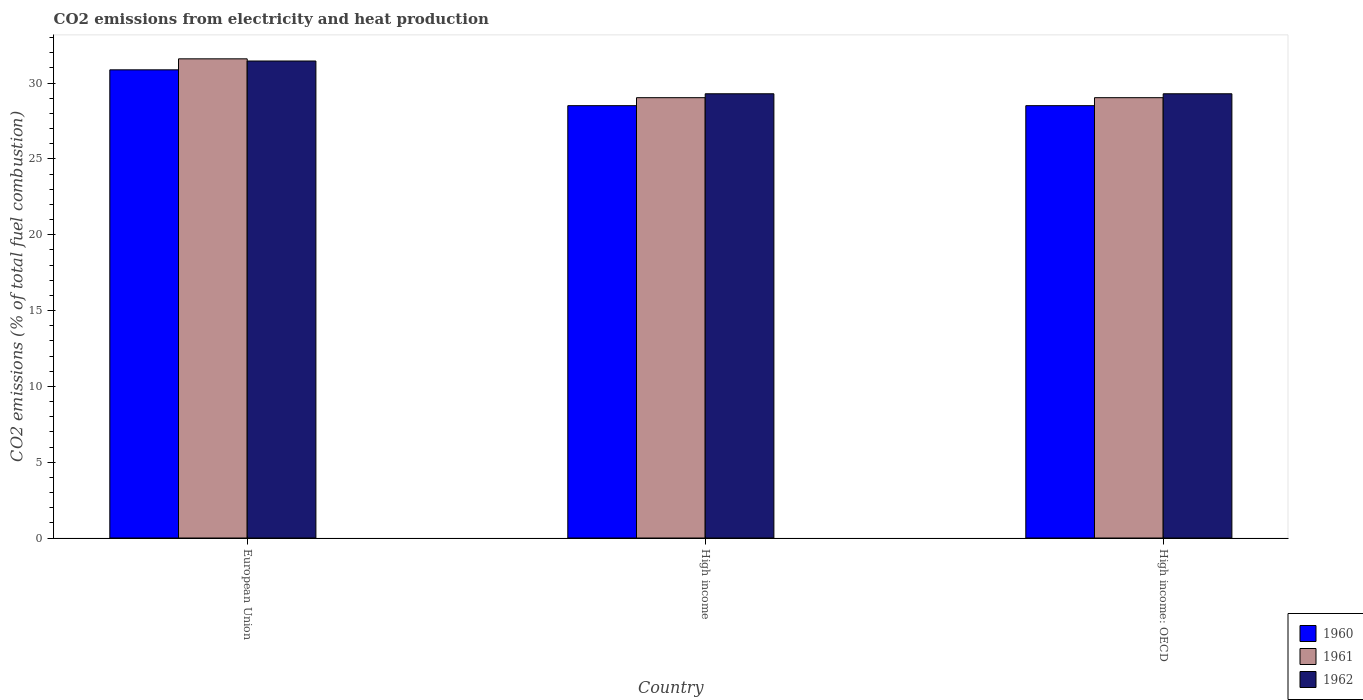How many different coloured bars are there?
Make the answer very short. 3. Are the number of bars per tick equal to the number of legend labels?
Provide a short and direct response. Yes. How many bars are there on the 1st tick from the left?
Keep it short and to the point. 3. What is the amount of CO2 emitted in 1962 in European Union?
Keep it short and to the point. 31.45. Across all countries, what is the maximum amount of CO2 emitted in 1962?
Give a very brief answer. 31.45. Across all countries, what is the minimum amount of CO2 emitted in 1961?
Provide a succinct answer. 29.03. In which country was the amount of CO2 emitted in 1962 minimum?
Offer a very short reply. High income. What is the total amount of CO2 emitted in 1960 in the graph?
Your response must be concise. 87.88. What is the difference between the amount of CO2 emitted in 1960 in High income: OECD and the amount of CO2 emitted in 1961 in European Union?
Make the answer very short. -3.09. What is the average amount of CO2 emitted in 1960 per country?
Offer a very short reply. 29.29. What is the difference between the amount of CO2 emitted of/in 1960 and amount of CO2 emitted of/in 1961 in European Union?
Offer a terse response. -0.73. What is the ratio of the amount of CO2 emitted in 1962 in European Union to that in High income: OECD?
Keep it short and to the point. 1.07. Is the amount of CO2 emitted in 1961 in European Union less than that in High income: OECD?
Your response must be concise. No. What is the difference between the highest and the second highest amount of CO2 emitted in 1960?
Give a very brief answer. -2.36. What is the difference between the highest and the lowest amount of CO2 emitted in 1962?
Offer a terse response. 2.16. In how many countries, is the amount of CO2 emitted in 1962 greater than the average amount of CO2 emitted in 1962 taken over all countries?
Provide a succinct answer. 1. Is the sum of the amount of CO2 emitted in 1960 in High income and High income: OECD greater than the maximum amount of CO2 emitted in 1961 across all countries?
Offer a terse response. Yes. What does the 3rd bar from the right in High income represents?
Give a very brief answer. 1960. Is it the case that in every country, the sum of the amount of CO2 emitted in 1962 and amount of CO2 emitted in 1960 is greater than the amount of CO2 emitted in 1961?
Make the answer very short. Yes. Are all the bars in the graph horizontal?
Provide a succinct answer. No. How many countries are there in the graph?
Make the answer very short. 3. Are the values on the major ticks of Y-axis written in scientific E-notation?
Your response must be concise. No. Where does the legend appear in the graph?
Ensure brevity in your answer.  Bottom right. How many legend labels are there?
Make the answer very short. 3. What is the title of the graph?
Your answer should be compact. CO2 emissions from electricity and heat production. Does "1975" appear as one of the legend labels in the graph?
Your response must be concise. No. What is the label or title of the Y-axis?
Offer a very short reply. CO2 emissions (% of total fuel combustion). What is the CO2 emissions (% of total fuel combustion) of 1960 in European Union?
Provide a short and direct response. 30.87. What is the CO2 emissions (% of total fuel combustion) in 1961 in European Union?
Make the answer very short. 31.59. What is the CO2 emissions (% of total fuel combustion) in 1962 in European Union?
Your answer should be very brief. 31.45. What is the CO2 emissions (% of total fuel combustion) of 1960 in High income?
Offer a terse response. 28.51. What is the CO2 emissions (% of total fuel combustion) of 1961 in High income?
Ensure brevity in your answer.  29.03. What is the CO2 emissions (% of total fuel combustion) in 1962 in High income?
Your response must be concise. 29.29. What is the CO2 emissions (% of total fuel combustion) of 1960 in High income: OECD?
Provide a short and direct response. 28.51. What is the CO2 emissions (% of total fuel combustion) in 1961 in High income: OECD?
Offer a terse response. 29.03. What is the CO2 emissions (% of total fuel combustion) in 1962 in High income: OECD?
Make the answer very short. 29.29. Across all countries, what is the maximum CO2 emissions (% of total fuel combustion) of 1960?
Keep it short and to the point. 30.87. Across all countries, what is the maximum CO2 emissions (% of total fuel combustion) in 1961?
Offer a very short reply. 31.59. Across all countries, what is the maximum CO2 emissions (% of total fuel combustion) of 1962?
Provide a succinct answer. 31.45. Across all countries, what is the minimum CO2 emissions (% of total fuel combustion) of 1960?
Ensure brevity in your answer.  28.51. Across all countries, what is the minimum CO2 emissions (% of total fuel combustion) in 1961?
Offer a terse response. 29.03. Across all countries, what is the minimum CO2 emissions (% of total fuel combustion) in 1962?
Your answer should be compact. 29.29. What is the total CO2 emissions (% of total fuel combustion) in 1960 in the graph?
Offer a terse response. 87.88. What is the total CO2 emissions (% of total fuel combustion) in 1961 in the graph?
Your answer should be compact. 89.66. What is the total CO2 emissions (% of total fuel combustion) of 1962 in the graph?
Keep it short and to the point. 90.03. What is the difference between the CO2 emissions (% of total fuel combustion) of 1960 in European Union and that in High income?
Ensure brevity in your answer.  2.36. What is the difference between the CO2 emissions (% of total fuel combustion) in 1961 in European Union and that in High income?
Offer a very short reply. 2.56. What is the difference between the CO2 emissions (% of total fuel combustion) in 1962 in European Union and that in High income?
Keep it short and to the point. 2.16. What is the difference between the CO2 emissions (% of total fuel combustion) of 1960 in European Union and that in High income: OECD?
Make the answer very short. 2.36. What is the difference between the CO2 emissions (% of total fuel combustion) of 1961 in European Union and that in High income: OECD?
Ensure brevity in your answer.  2.56. What is the difference between the CO2 emissions (% of total fuel combustion) in 1962 in European Union and that in High income: OECD?
Make the answer very short. 2.16. What is the difference between the CO2 emissions (% of total fuel combustion) in 1960 in European Union and the CO2 emissions (% of total fuel combustion) in 1961 in High income?
Offer a terse response. 1.84. What is the difference between the CO2 emissions (% of total fuel combustion) of 1960 in European Union and the CO2 emissions (% of total fuel combustion) of 1962 in High income?
Offer a terse response. 1.58. What is the difference between the CO2 emissions (% of total fuel combustion) in 1961 in European Union and the CO2 emissions (% of total fuel combustion) in 1962 in High income?
Your response must be concise. 2.3. What is the difference between the CO2 emissions (% of total fuel combustion) of 1960 in European Union and the CO2 emissions (% of total fuel combustion) of 1961 in High income: OECD?
Your response must be concise. 1.84. What is the difference between the CO2 emissions (% of total fuel combustion) in 1960 in European Union and the CO2 emissions (% of total fuel combustion) in 1962 in High income: OECD?
Your response must be concise. 1.58. What is the difference between the CO2 emissions (% of total fuel combustion) in 1961 in European Union and the CO2 emissions (% of total fuel combustion) in 1962 in High income: OECD?
Keep it short and to the point. 2.3. What is the difference between the CO2 emissions (% of total fuel combustion) of 1960 in High income and the CO2 emissions (% of total fuel combustion) of 1961 in High income: OECD?
Offer a terse response. -0.53. What is the difference between the CO2 emissions (% of total fuel combustion) in 1960 in High income and the CO2 emissions (% of total fuel combustion) in 1962 in High income: OECD?
Give a very brief answer. -0.78. What is the difference between the CO2 emissions (% of total fuel combustion) in 1961 in High income and the CO2 emissions (% of total fuel combustion) in 1962 in High income: OECD?
Your response must be concise. -0.26. What is the average CO2 emissions (% of total fuel combustion) in 1960 per country?
Offer a terse response. 29.29. What is the average CO2 emissions (% of total fuel combustion) in 1961 per country?
Make the answer very short. 29.89. What is the average CO2 emissions (% of total fuel combustion) in 1962 per country?
Offer a terse response. 30.01. What is the difference between the CO2 emissions (% of total fuel combustion) in 1960 and CO2 emissions (% of total fuel combustion) in 1961 in European Union?
Give a very brief answer. -0.73. What is the difference between the CO2 emissions (% of total fuel combustion) of 1960 and CO2 emissions (% of total fuel combustion) of 1962 in European Union?
Your answer should be compact. -0.58. What is the difference between the CO2 emissions (% of total fuel combustion) in 1961 and CO2 emissions (% of total fuel combustion) in 1962 in European Union?
Provide a succinct answer. 0.14. What is the difference between the CO2 emissions (% of total fuel combustion) of 1960 and CO2 emissions (% of total fuel combustion) of 1961 in High income?
Your response must be concise. -0.53. What is the difference between the CO2 emissions (% of total fuel combustion) of 1960 and CO2 emissions (% of total fuel combustion) of 1962 in High income?
Your response must be concise. -0.78. What is the difference between the CO2 emissions (% of total fuel combustion) of 1961 and CO2 emissions (% of total fuel combustion) of 1962 in High income?
Provide a succinct answer. -0.26. What is the difference between the CO2 emissions (% of total fuel combustion) in 1960 and CO2 emissions (% of total fuel combustion) in 1961 in High income: OECD?
Ensure brevity in your answer.  -0.53. What is the difference between the CO2 emissions (% of total fuel combustion) in 1960 and CO2 emissions (% of total fuel combustion) in 1962 in High income: OECD?
Provide a short and direct response. -0.78. What is the difference between the CO2 emissions (% of total fuel combustion) of 1961 and CO2 emissions (% of total fuel combustion) of 1962 in High income: OECD?
Make the answer very short. -0.26. What is the ratio of the CO2 emissions (% of total fuel combustion) in 1960 in European Union to that in High income?
Your answer should be compact. 1.08. What is the ratio of the CO2 emissions (% of total fuel combustion) of 1961 in European Union to that in High income?
Keep it short and to the point. 1.09. What is the ratio of the CO2 emissions (% of total fuel combustion) of 1962 in European Union to that in High income?
Your answer should be very brief. 1.07. What is the ratio of the CO2 emissions (% of total fuel combustion) in 1960 in European Union to that in High income: OECD?
Offer a very short reply. 1.08. What is the ratio of the CO2 emissions (% of total fuel combustion) of 1961 in European Union to that in High income: OECD?
Provide a succinct answer. 1.09. What is the ratio of the CO2 emissions (% of total fuel combustion) in 1962 in European Union to that in High income: OECD?
Keep it short and to the point. 1.07. What is the ratio of the CO2 emissions (% of total fuel combustion) of 1960 in High income to that in High income: OECD?
Ensure brevity in your answer.  1. What is the ratio of the CO2 emissions (% of total fuel combustion) of 1961 in High income to that in High income: OECD?
Offer a terse response. 1. What is the difference between the highest and the second highest CO2 emissions (% of total fuel combustion) of 1960?
Your response must be concise. 2.36. What is the difference between the highest and the second highest CO2 emissions (% of total fuel combustion) of 1961?
Keep it short and to the point. 2.56. What is the difference between the highest and the second highest CO2 emissions (% of total fuel combustion) in 1962?
Offer a terse response. 2.16. What is the difference between the highest and the lowest CO2 emissions (% of total fuel combustion) of 1960?
Ensure brevity in your answer.  2.36. What is the difference between the highest and the lowest CO2 emissions (% of total fuel combustion) of 1961?
Your answer should be compact. 2.56. What is the difference between the highest and the lowest CO2 emissions (% of total fuel combustion) of 1962?
Keep it short and to the point. 2.16. 